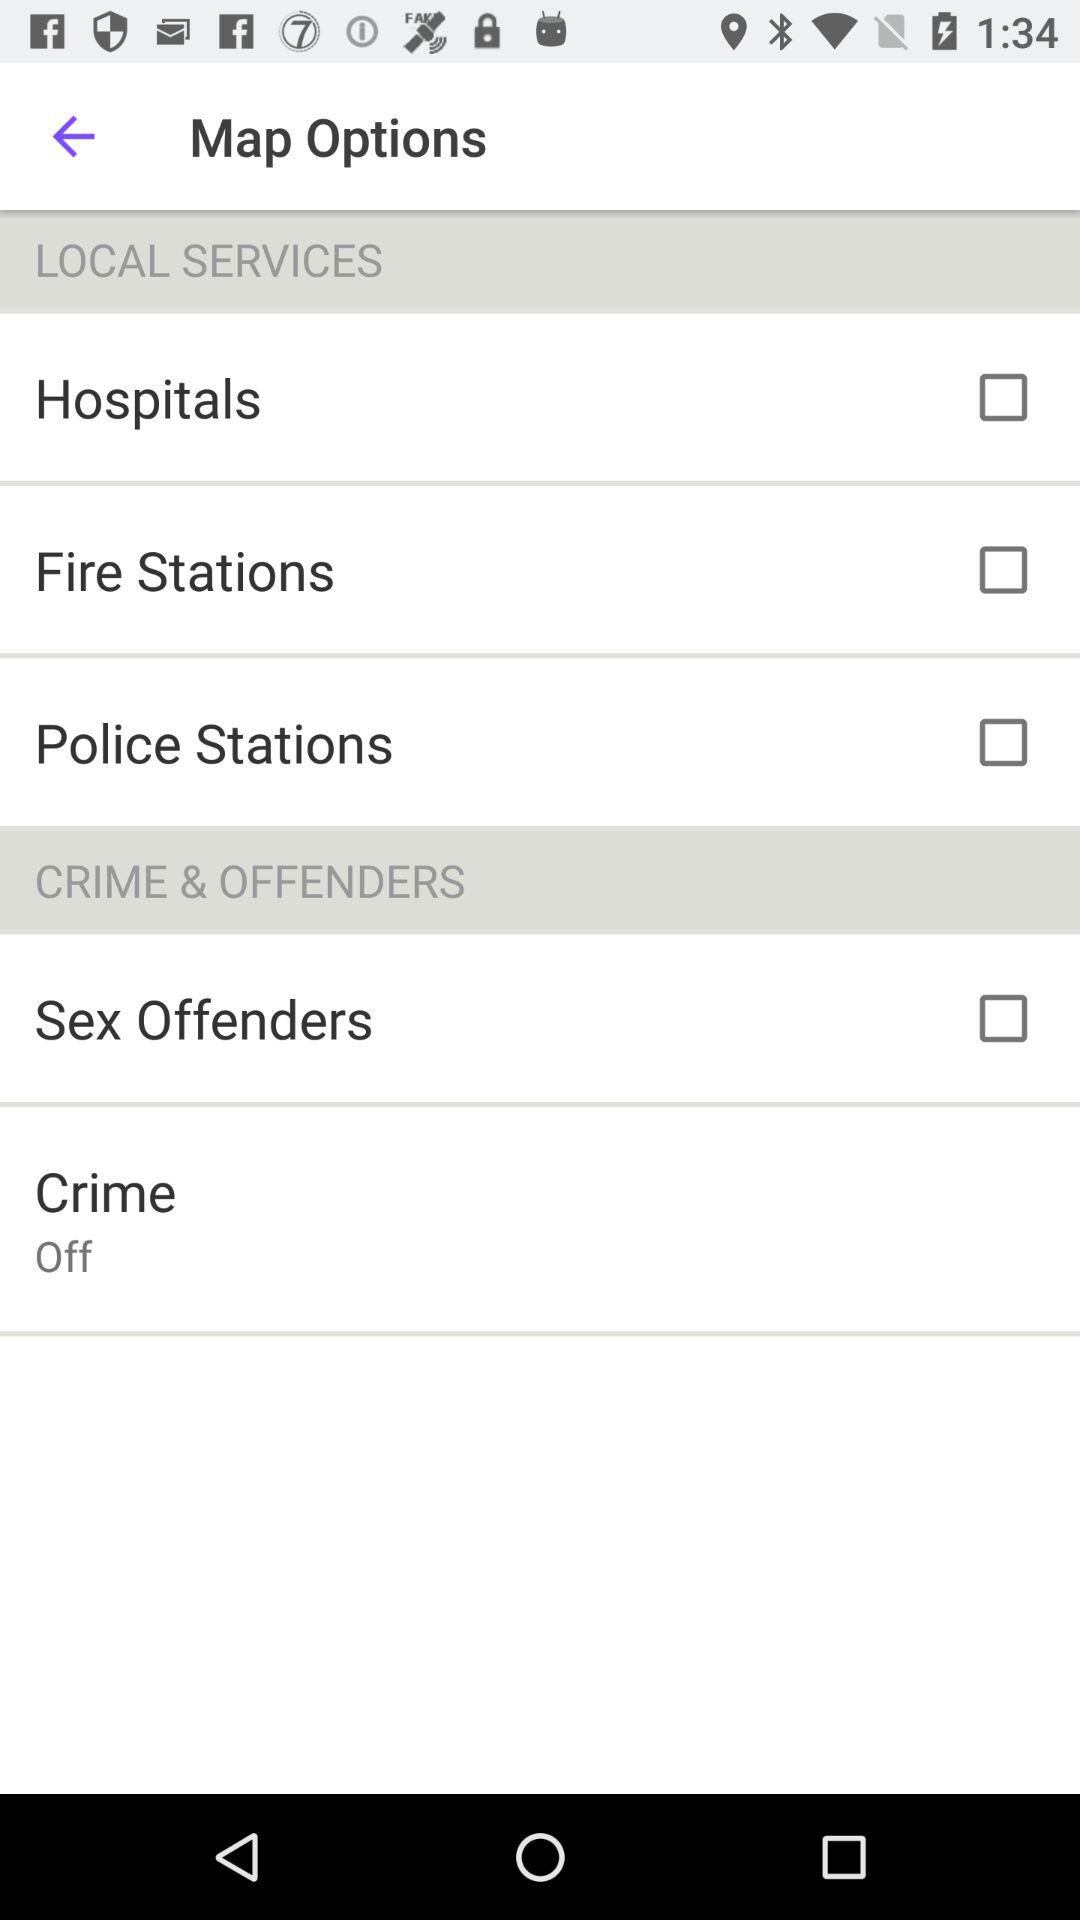Is "CRIME & OFFENDERS" selected or not?
When the provided information is insufficient, respond with <no answer>. <no answer> 